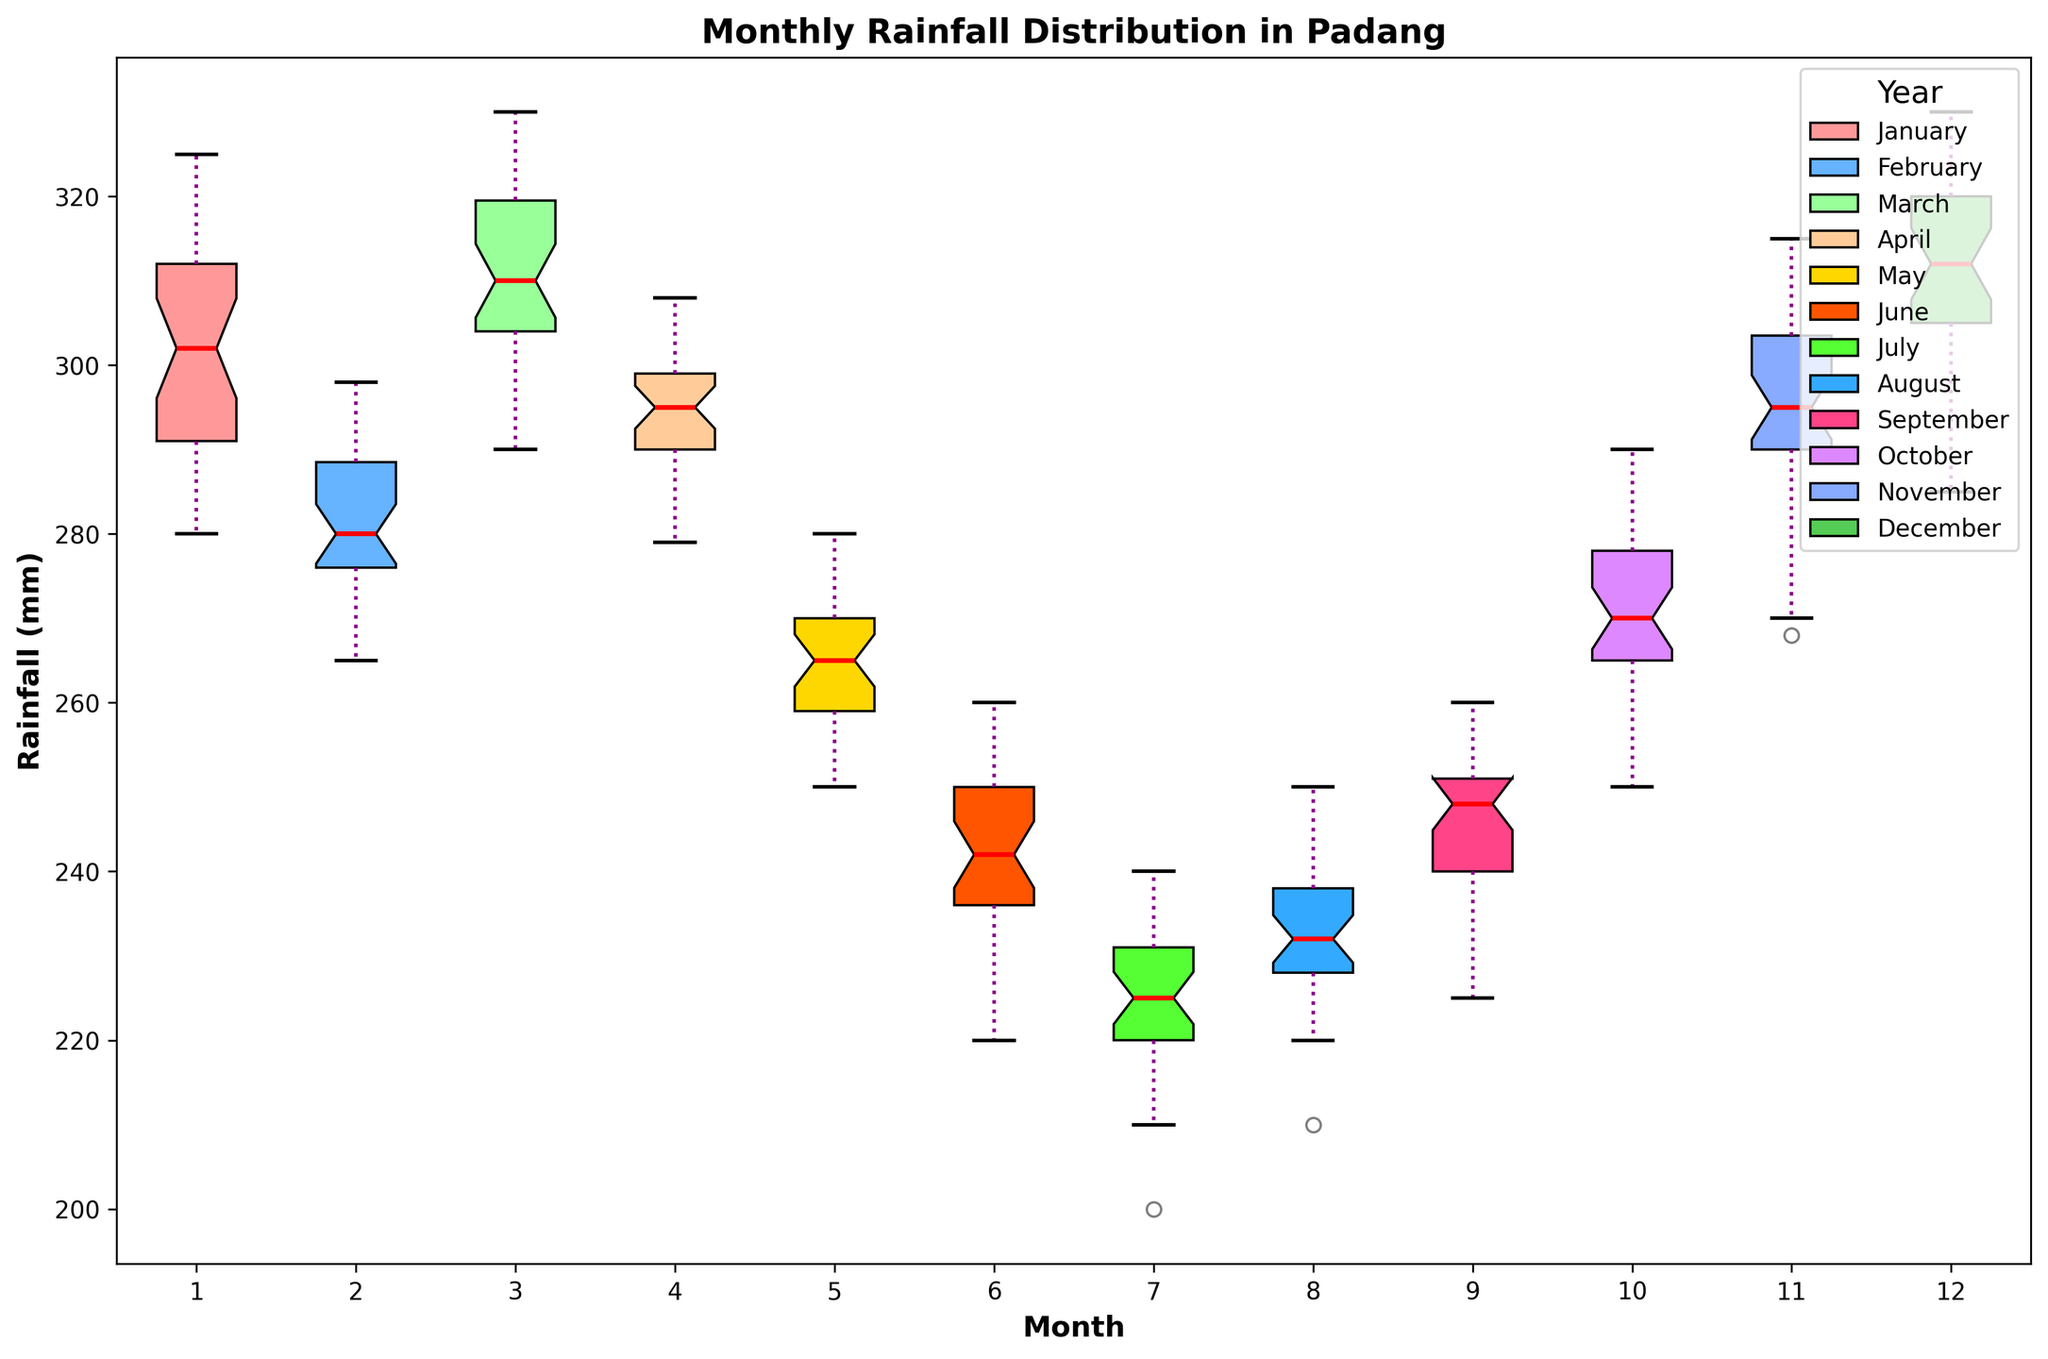what is the median rainfall in January? To find the median rainfall in January, look at the center line inside the box plot for January.
Answer: 302 mm Which month has the highest median rainfall? Compare the center lines (medians) of all the box plots to identify the highest one.
Answer: December Which month shows the most variability in rainfall? The month with the largest interquartile range (IQR) will have the tallest box, indicating the most variability.
Answer: March Which month has the least consistent rainfall values, and how can you tell? Look for the month with the widest range between the whiskers, indicating the least consistent or most spread-out rainfall values.
Answer: March How does the median rainfall in June compare to that in July? Compare the medians (center lines in the boxes) of June and July box plots.
Answer: June's median is slightly higher than July's Did January ever have a year with less than 280 mm of rainfall? Check the lower whisker (minimum value) of the January box plot for values below 280 mm.
Answer: Yes For which month is the median rainfall closest to 275 mm? Look for the median lines (center lines in the boxes) that are closest to 275 mm across all months.
Answer: October What's the difference between the maximum rainfall in May and the maximum rainfall in June? Compare the top whisker (maximum value) of the May and June box plots, then subtract the maximum of June from the maximum of May.
Answer: 275 - 260 = 15 mm Which months have medians below 250 mm? Look for the medians (center lines in the boxes) below 250 mm.
Answer: May, June, and July In how many months is the interquartile range (IQR) less than 30 mm? Identify the months where the height of the box (IQR) is visibly less than 30 mm. Count those months.
Answer: 3 (July, June, and May) 